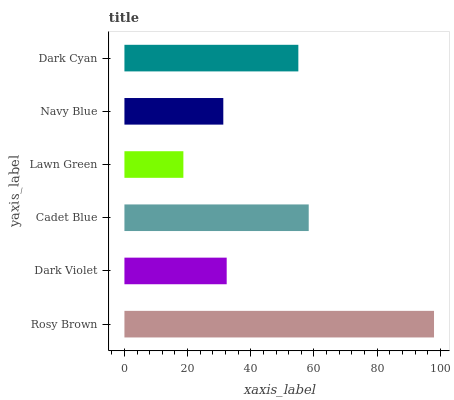Is Lawn Green the minimum?
Answer yes or no. Yes. Is Rosy Brown the maximum?
Answer yes or no. Yes. Is Dark Violet the minimum?
Answer yes or no. No. Is Dark Violet the maximum?
Answer yes or no. No. Is Rosy Brown greater than Dark Violet?
Answer yes or no. Yes. Is Dark Violet less than Rosy Brown?
Answer yes or no. Yes. Is Dark Violet greater than Rosy Brown?
Answer yes or no. No. Is Rosy Brown less than Dark Violet?
Answer yes or no. No. Is Dark Cyan the high median?
Answer yes or no. Yes. Is Dark Violet the low median?
Answer yes or no. Yes. Is Dark Violet the high median?
Answer yes or no. No. Is Lawn Green the low median?
Answer yes or no. No. 